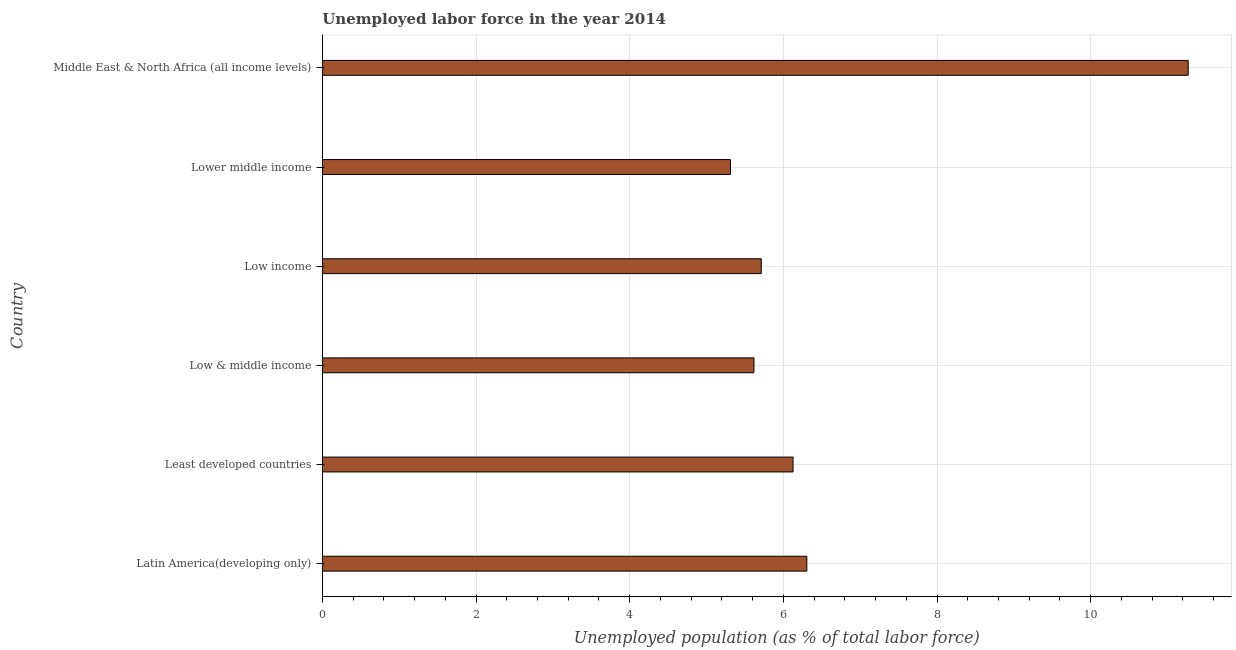Does the graph contain any zero values?
Give a very brief answer. No. What is the title of the graph?
Keep it short and to the point. Unemployed labor force in the year 2014. What is the label or title of the X-axis?
Make the answer very short. Unemployed population (as % of total labor force). What is the total unemployed population in Lower middle income?
Provide a succinct answer. 5.31. Across all countries, what is the maximum total unemployed population?
Give a very brief answer. 11.27. Across all countries, what is the minimum total unemployed population?
Provide a succinct answer. 5.31. In which country was the total unemployed population maximum?
Provide a succinct answer. Middle East & North Africa (all income levels). In which country was the total unemployed population minimum?
Give a very brief answer. Lower middle income. What is the sum of the total unemployed population?
Ensure brevity in your answer.  40.34. What is the difference between the total unemployed population in Latin America(developing only) and Low income?
Provide a succinct answer. 0.59. What is the average total unemployed population per country?
Make the answer very short. 6.72. What is the median total unemployed population?
Your answer should be very brief. 5.92. In how many countries, is the total unemployed population greater than 2.8 %?
Give a very brief answer. 6. What is the ratio of the total unemployed population in Least developed countries to that in Low & middle income?
Give a very brief answer. 1.09. Is the total unemployed population in Least developed countries less than that in Middle East & North Africa (all income levels)?
Your response must be concise. Yes. Is the difference between the total unemployed population in Low income and Middle East & North Africa (all income levels) greater than the difference between any two countries?
Offer a terse response. No. What is the difference between the highest and the second highest total unemployed population?
Offer a very short reply. 4.96. Is the sum of the total unemployed population in Low income and Middle East & North Africa (all income levels) greater than the maximum total unemployed population across all countries?
Provide a short and direct response. Yes. What is the difference between the highest and the lowest total unemployed population?
Offer a terse response. 5.96. In how many countries, is the total unemployed population greater than the average total unemployed population taken over all countries?
Your response must be concise. 1. Are all the bars in the graph horizontal?
Give a very brief answer. Yes. How many countries are there in the graph?
Give a very brief answer. 6. What is the Unemployed population (as % of total labor force) in Latin America(developing only)?
Keep it short and to the point. 6.31. What is the Unemployed population (as % of total labor force) of Least developed countries?
Provide a short and direct response. 6.13. What is the Unemployed population (as % of total labor force) of Low & middle income?
Provide a succinct answer. 5.62. What is the Unemployed population (as % of total labor force) in Low income?
Your answer should be compact. 5.71. What is the Unemployed population (as % of total labor force) in Lower middle income?
Your answer should be compact. 5.31. What is the Unemployed population (as % of total labor force) of Middle East & North Africa (all income levels)?
Your response must be concise. 11.27. What is the difference between the Unemployed population (as % of total labor force) in Latin America(developing only) and Least developed countries?
Your answer should be very brief. 0.18. What is the difference between the Unemployed population (as % of total labor force) in Latin America(developing only) and Low & middle income?
Your response must be concise. 0.69. What is the difference between the Unemployed population (as % of total labor force) in Latin America(developing only) and Low income?
Your answer should be compact. 0.59. What is the difference between the Unemployed population (as % of total labor force) in Latin America(developing only) and Lower middle income?
Provide a short and direct response. 0.99. What is the difference between the Unemployed population (as % of total labor force) in Latin America(developing only) and Middle East & North Africa (all income levels)?
Provide a short and direct response. -4.96. What is the difference between the Unemployed population (as % of total labor force) in Least developed countries and Low & middle income?
Offer a very short reply. 0.51. What is the difference between the Unemployed population (as % of total labor force) in Least developed countries and Low income?
Your answer should be compact. 0.41. What is the difference between the Unemployed population (as % of total labor force) in Least developed countries and Lower middle income?
Your answer should be compact. 0.81. What is the difference between the Unemployed population (as % of total labor force) in Least developed countries and Middle East & North Africa (all income levels)?
Ensure brevity in your answer.  -5.14. What is the difference between the Unemployed population (as % of total labor force) in Low & middle income and Low income?
Give a very brief answer. -0.09. What is the difference between the Unemployed population (as % of total labor force) in Low & middle income and Lower middle income?
Make the answer very short. 0.31. What is the difference between the Unemployed population (as % of total labor force) in Low & middle income and Middle East & North Africa (all income levels)?
Ensure brevity in your answer.  -5.65. What is the difference between the Unemployed population (as % of total labor force) in Low income and Lower middle income?
Make the answer very short. 0.4. What is the difference between the Unemployed population (as % of total labor force) in Low income and Middle East & North Africa (all income levels)?
Provide a short and direct response. -5.56. What is the difference between the Unemployed population (as % of total labor force) in Lower middle income and Middle East & North Africa (all income levels)?
Your answer should be very brief. -5.96. What is the ratio of the Unemployed population (as % of total labor force) in Latin America(developing only) to that in Low & middle income?
Provide a short and direct response. 1.12. What is the ratio of the Unemployed population (as % of total labor force) in Latin America(developing only) to that in Low income?
Make the answer very short. 1.1. What is the ratio of the Unemployed population (as % of total labor force) in Latin America(developing only) to that in Lower middle income?
Offer a terse response. 1.19. What is the ratio of the Unemployed population (as % of total labor force) in Latin America(developing only) to that in Middle East & North Africa (all income levels)?
Make the answer very short. 0.56. What is the ratio of the Unemployed population (as % of total labor force) in Least developed countries to that in Low & middle income?
Your answer should be very brief. 1.09. What is the ratio of the Unemployed population (as % of total labor force) in Least developed countries to that in Low income?
Your response must be concise. 1.07. What is the ratio of the Unemployed population (as % of total labor force) in Least developed countries to that in Lower middle income?
Make the answer very short. 1.15. What is the ratio of the Unemployed population (as % of total labor force) in Least developed countries to that in Middle East & North Africa (all income levels)?
Your answer should be very brief. 0.54. What is the ratio of the Unemployed population (as % of total labor force) in Low & middle income to that in Lower middle income?
Provide a succinct answer. 1.06. What is the ratio of the Unemployed population (as % of total labor force) in Low & middle income to that in Middle East & North Africa (all income levels)?
Your answer should be very brief. 0.5. What is the ratio of the Unemployed population (as % of total labor force) in Low income to that in Lower middle income?
Offer a terse response. 1.07. What is the ratio of the Unemployed population (as % of total labor force) in Low income to that in Middle East & North Africa (all income levels)?
Ensure brevity in your answer.  0.51. What is the ratio of the Unemployed population (as % of total labor force) in Lower middle income to that in Middle East & North Africa (all income levels)?
Keep it short and to the point. 0.47. 